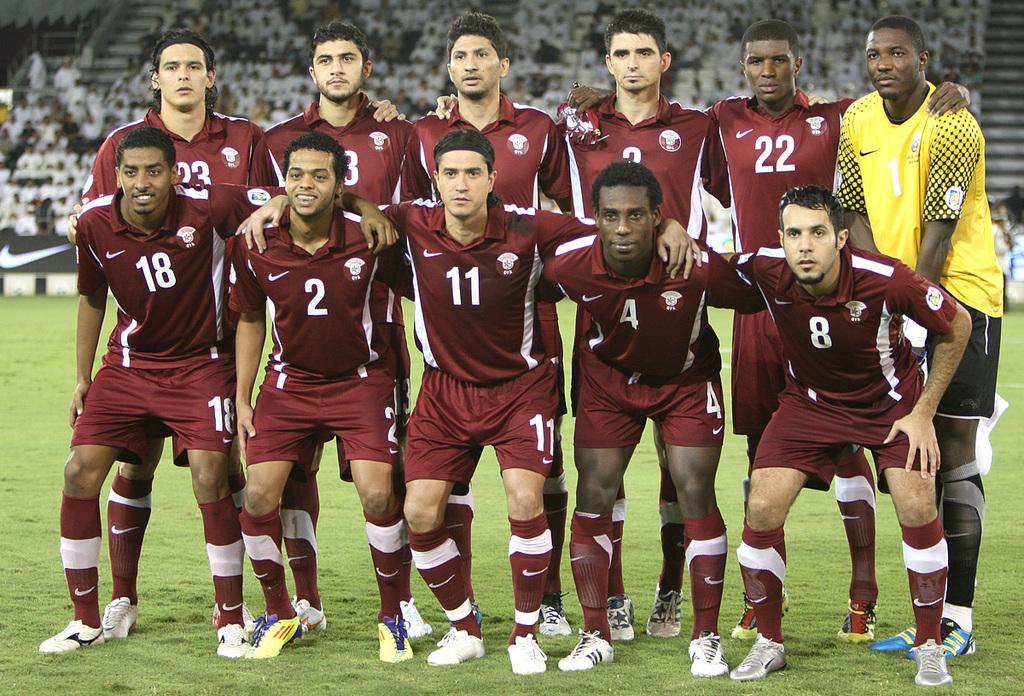<image>
Write a terse but informative summary of the picture. In a team photo, numbers 18 and 2 are the only ones who smile. 